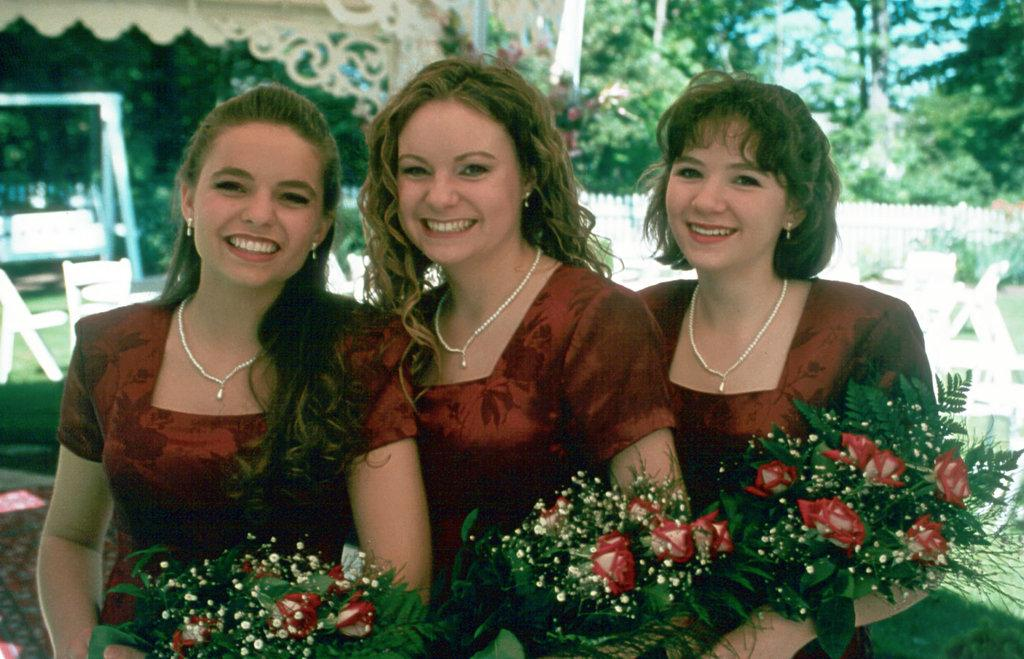How many women are in the image? There are three women in the image. What are the women doing in the image? The women are smiling and holding flower bouquets. What can be seen in the background of the image? There are chairs, a fence, plants, trees, and other objects in the background of the image. Where is the faucet located in the image? There is no faucet present in the image. What type of knot is the queen using to secure her crown in the image? There is no queen or crown present in the image. 